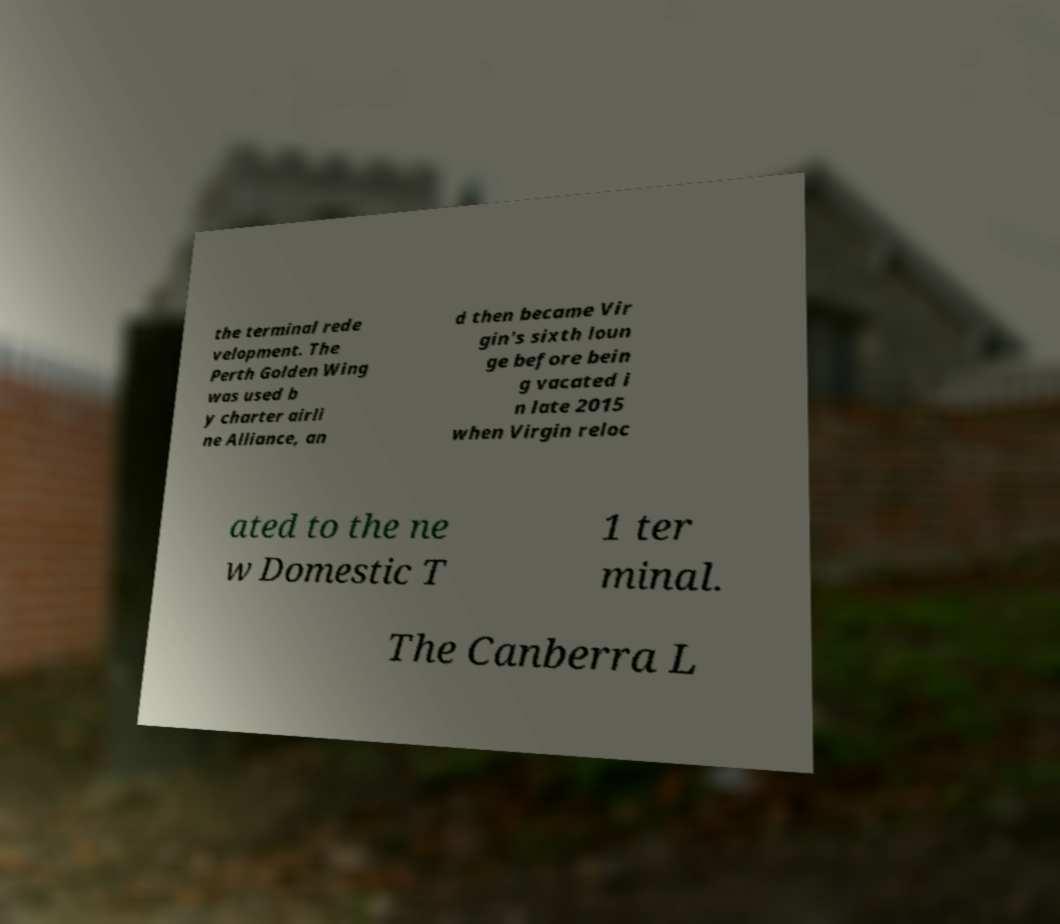For documentation purposes, I need the text within this image transcribed. Could you provide that? the terminal rede velopment. The Perth Golden Wing was used b y charter airli ne Alliance, an d then became Vir gin's sixth loun ge before bein g vacated i n late 2015 when Virgin reloc ated to the ne w Domestic T 1 ter minal. The Canberra L 